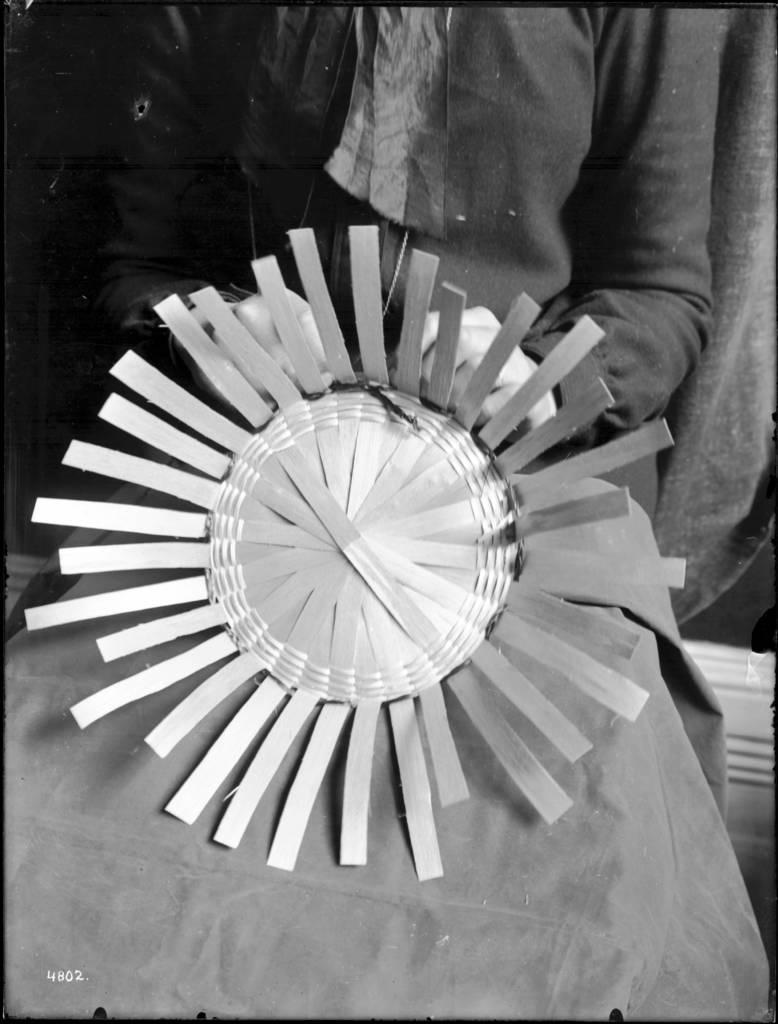Describe this image in one or two sentences. In the image a person is holding an object. 